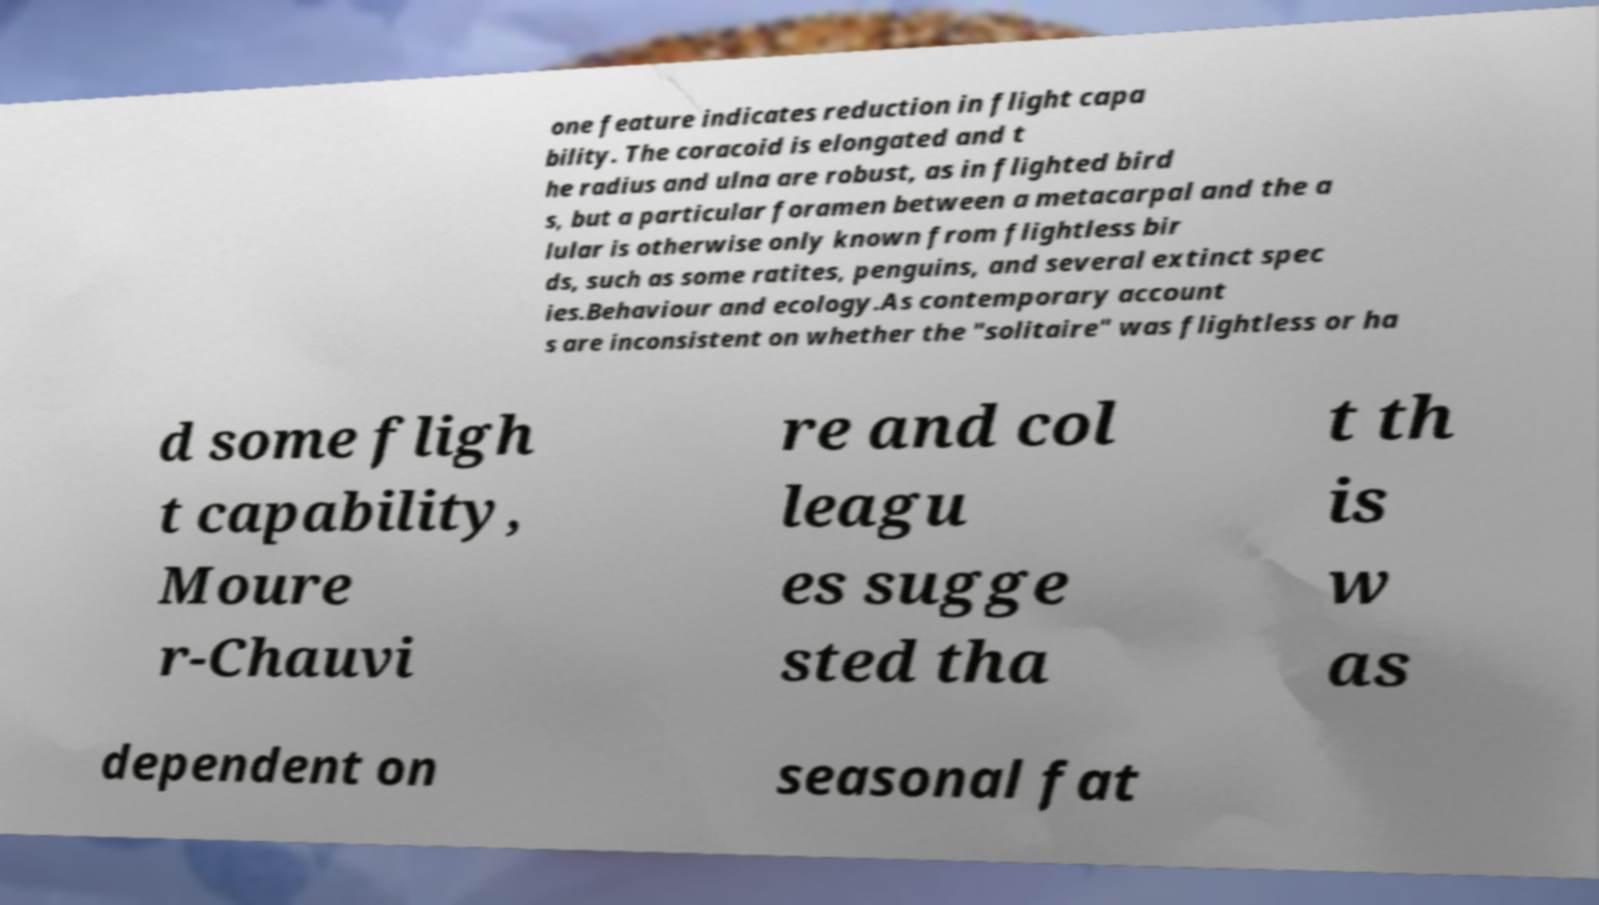For documentation purposes, I need the text within this image transcribed. Could you provide that? one feature indicates reduction in flight capa bility. The coracoid is elongated and t he radius and ulna are robust, as in flighted bird s, but a particular foramen between a metacarpal and the a lular is otherwise only known from flightless bir ds, such as some ratites, penguins, and several extinct spec ies.Behaviour and ecology.As contemporary account s are inconsistent on whether the "solitaire" was flightless or ha d some fligh t capability, Moure r-Chauvi re and col leagu es sugge sted tha t th is w as dependent on seasonal fat 